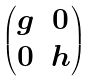<formula> <loc_0><loc_0><loc_500><loc_500>\begin{pmatrix} g & 0 \\ 0 & h \end{pmatrix}</formula> 